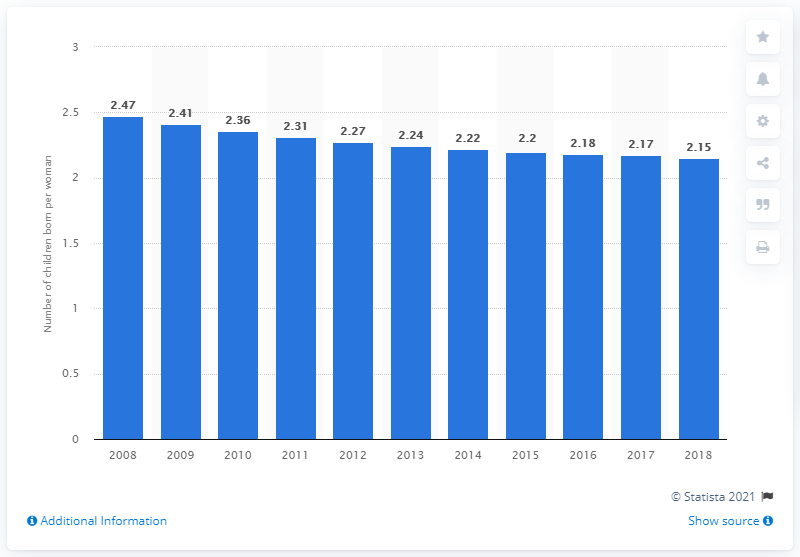Point out several critical features in this image. In 2018, the fertility rate in Burma was 2.15, indicating a stable population growth rate. 